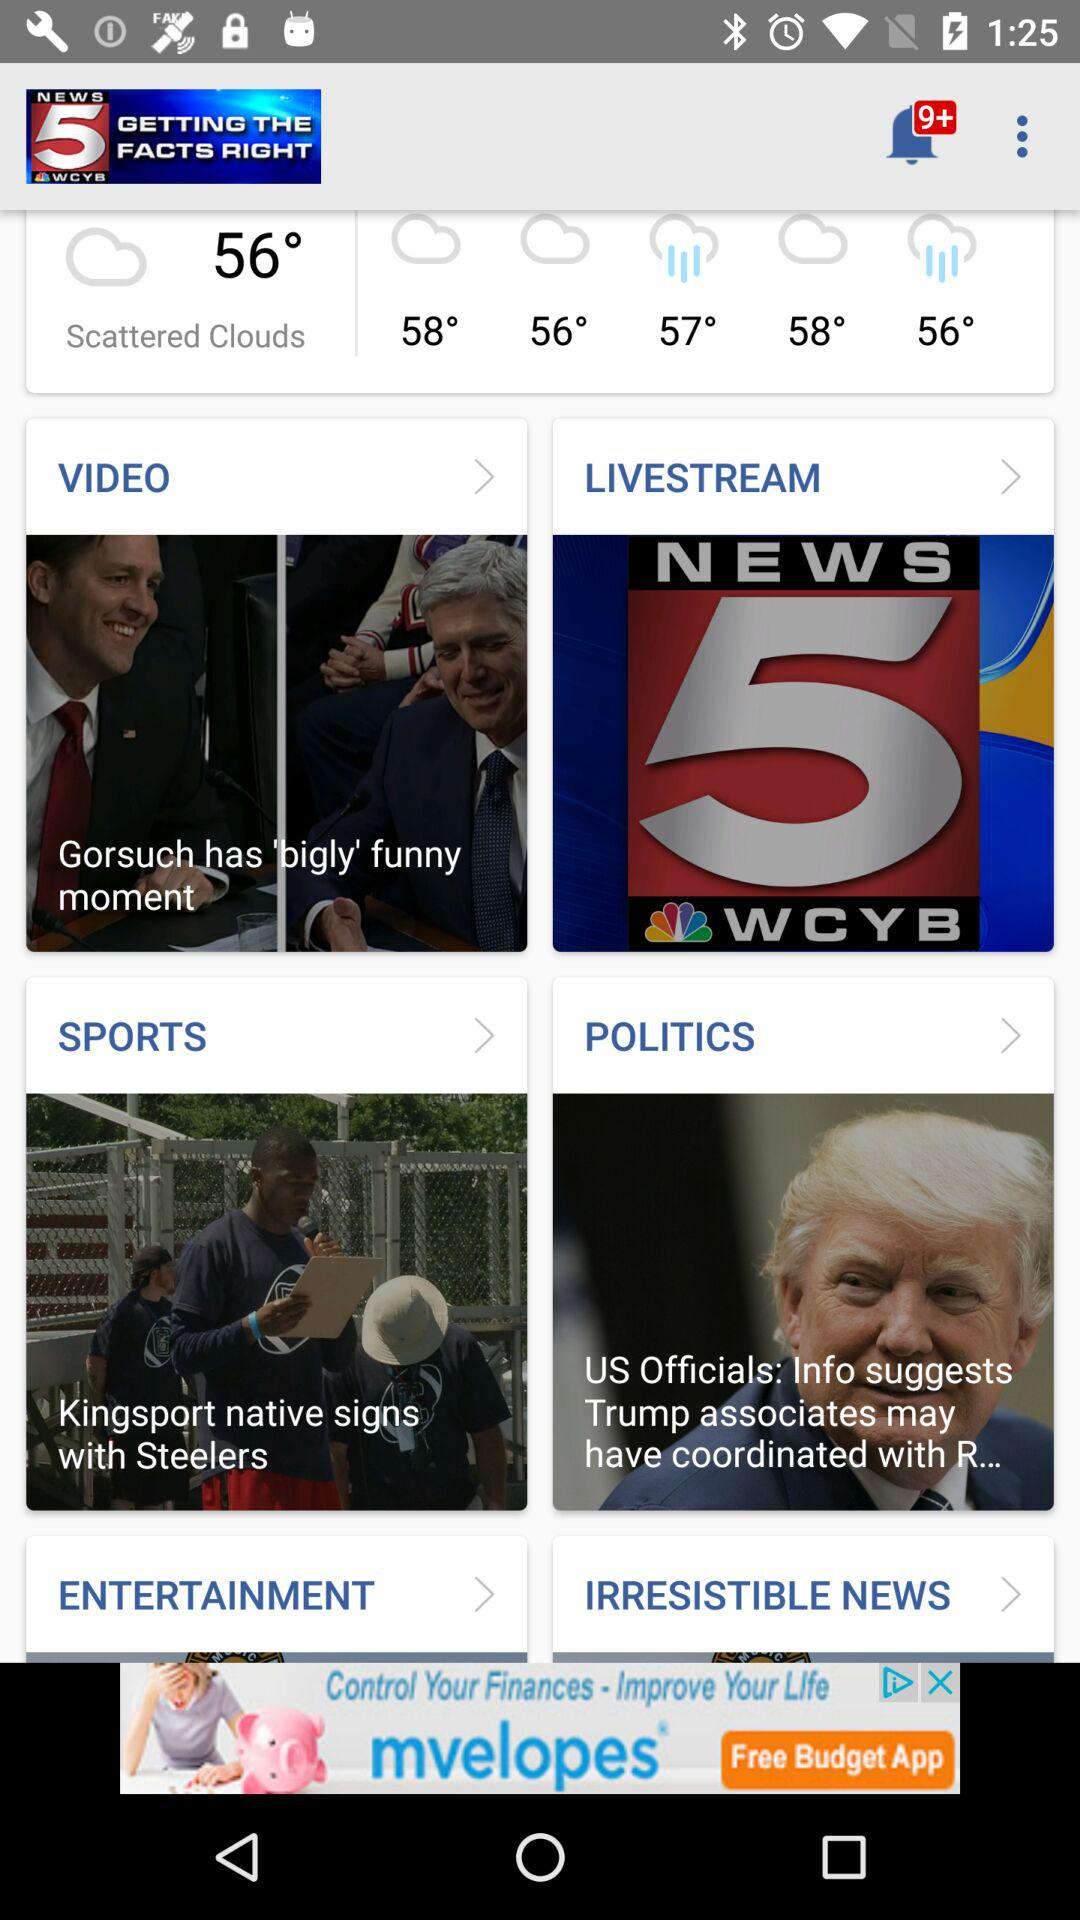How many degrees warmer is the temperature at 58 degrees than the temperature at 56 degrees?
Answer the question using a single word or phrase. 2 